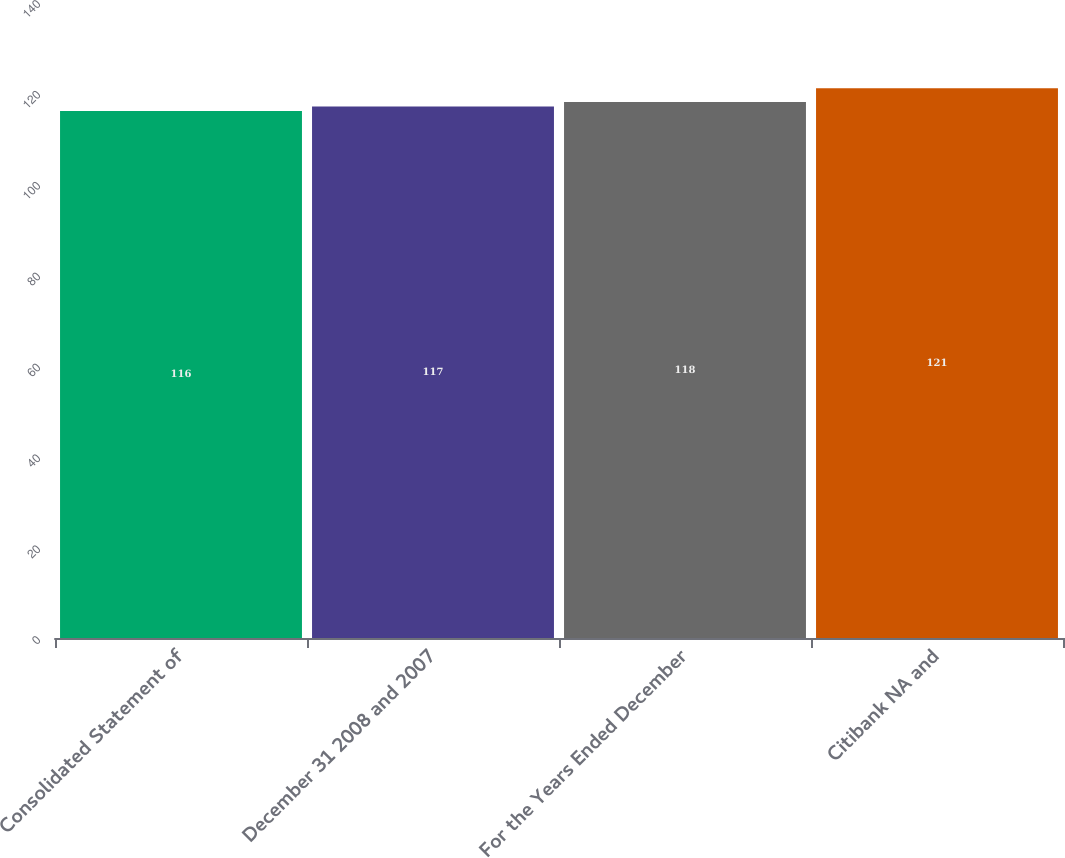Convert chart to OTSL. <chart><loc_0><loc_0><loc_500><loc_500><bar_chart><fcel>Consolidated Statement of<fcel>December 31 2008 and 2007<fcel>For the Years Ended December<fcel>Citibank NA and<nl><fcel>116<fcel>117<fcel>118<fcel>121<nl></chart> 